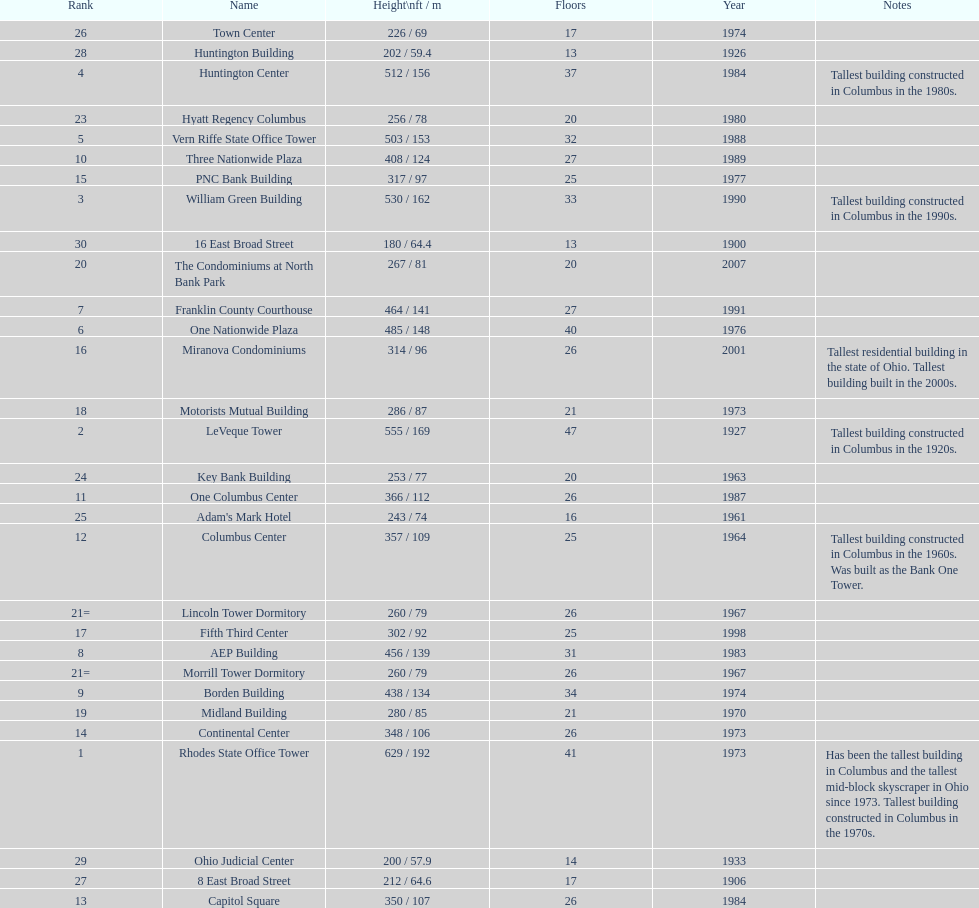Which is the tallest building? Rhodes State Office Tower. 